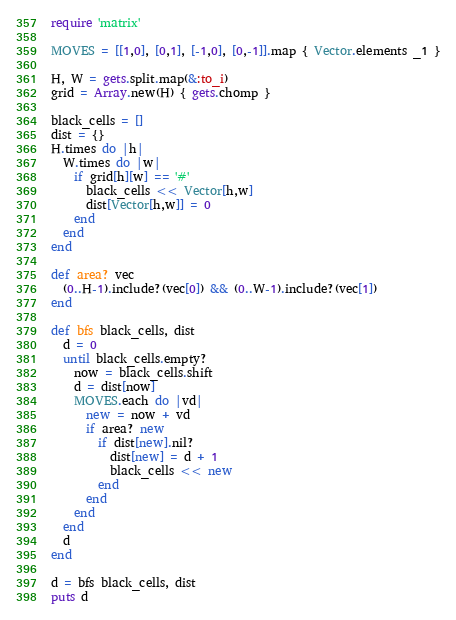Convert code to text. <code><loc_0><loc_0><loc_500><loc_500><_Ruby_>require 'matrix'

MOVES = [[1,0], [0,1], [-1,0], [0,-1]].map { Vector.elements _1 }

H, W = gets.split.map(&:to_i)
grid = Array.new(H) { gets.chomp }

black_cells = []
dist = {}
H.times do |h|
  W.times do |w|
    if grid[h][w] == '#'
      black_cells << Vector[h,w]
      dist[Vector[h,w]] = 0
    end
  end
end

def area? vec
  (0..H-1).include?(vec[0]) && (0..W-1).include?(vec[1])
end

def bfs black_cells, dist
  d = 0
  until black_cells.empty?
    now = black_cells.shift
    d = dist[now]
    MOVES.each do |vd|
      new = now + vd
      if area? new
        if dist[new].nil?
          dist[new] = d + 1
          black_cells << new
        end
      end
    end
  end
  d
end

d = bfs black_cells, dist
puts d</code> 